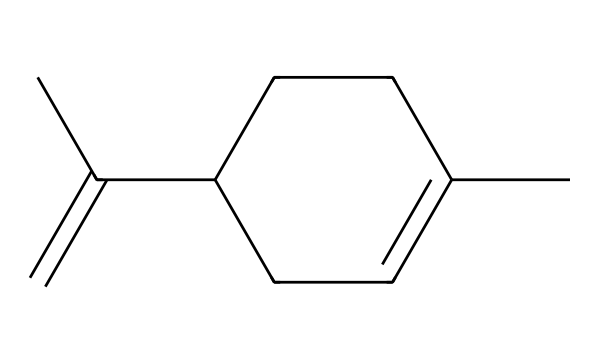What is the molecular formula of limonene? By analyzing the given SMILES representation, we can count the number of carbon (C) and hydrogen (H) atoms. The structure shows 10 carbon atoms and 16 hydrogen atoms, leading to the molecular formula C10H16.
Answer: C10H16 How many rings are present in the structure of limonene? The SMILES representation does not include any notation indicating a ring system, which shows that limonene is a linear or acyclic compound. We can confirm there are zero rings in the structure.
Answer: 0 What is the primary functional group in limonene? Looking at the SMILES representation, we can identify that limonene has a double bond (C=C). This indicates that the primary functional group present is a carbon-carbon double bond, characteristic of alkenes.
Answer: alkene Is limonene a saturated or unsaturated compound? In the chemical structure provided, there is a double bond which classifies limonene as an unsaturated compound. Saturated compounds only have single bonds, whereas unsaturated ones contain one or more double or triple bonds.
Answer: unsaturated How many double bonds are present in limonene? The SMILES code clearly shows one carbon-carbon double bond (C=C). Thus, we can conclude that there is a single double bond present in the limonene structure.
Answer: 1 What type of terpene is limonene classified as? Based on its structure, limonene has a bicyclic or monoterpene structure since it contains two carbon rings and comprises 10 carbon atoms. Monoterpenes are derived from two isoprene units.
Answer: monoterpene What type of aroma does limonene typically have? In traditional uses, especially within Indian cuisine, limonene is known for its citrus aroma, which comes from its presence in citrus fruits. This can be inferred from its source, and sustainability gives it a refreshing scent.
Answer: citrus 